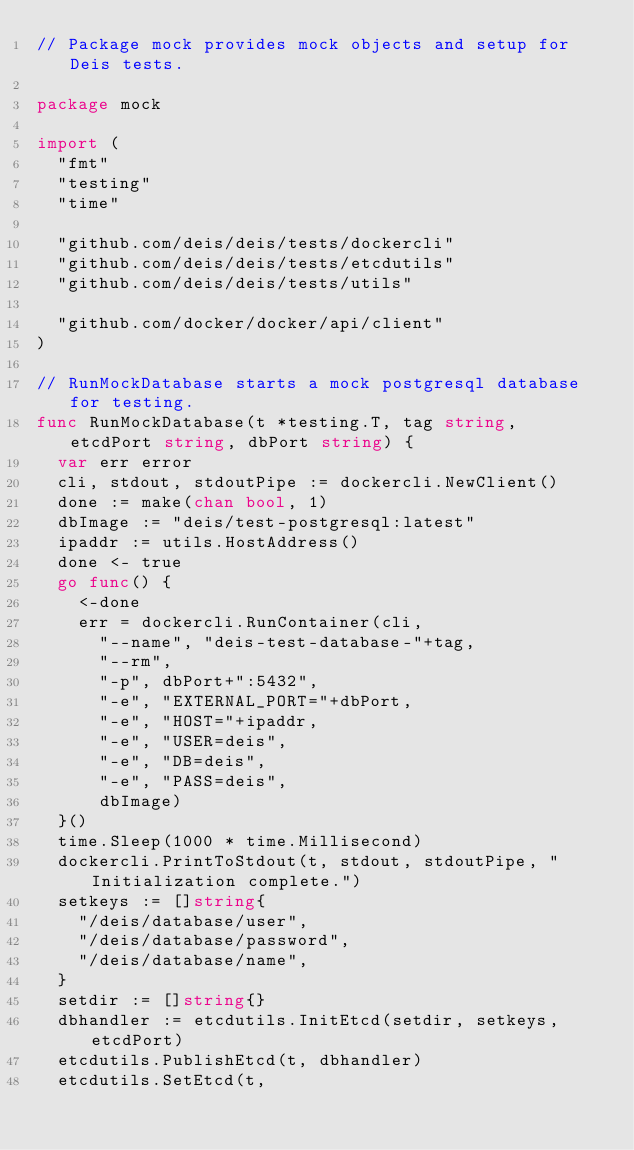<code> <loc_0><loc_0><loc_500><loc_500><_Go_>// Package mock provides mock objects and setup for Deis tests.

package mock

import (
	"fmt"
	"testing"
	"time"

	"github.com/deis/deis/tests/dockercli"
	"github.com/deis/deis/tests/etcdutils"
	"github.com/deis/deis/tests/utils"

	"github.com/docker/docker/api/client"
)

// RunMockDatabase starts a mock postgresql database for testing.
func RunMockDatabase(t *testing.T, tag string, etcdPort string, dbPort string) {
	var err error
	cli, stdout, stdoutPipe := dockercli.NewClient()
	done := make(chan bool, 1)
	dbImage := "deis/test-postgresql:latest"
	ipaddr := utils.HostAddress()
	done <- true
	go func() {
		<-done
		err = dockercli.RunContainer(cli,
			"--name", "deis-test-database-"+tag,
			"--rm",
			"-p", dbPort+":5432",
			"-e", "EXTERNAL_PORT="+dbPort,
			"-e", "HOST="+ipaddr,
			"-e", "USER=deis",
			"-e", "DB=deis",
			"-e", "PASS=deis",
			dbImage)
	}()
	time.Sleep(1000 * time.Millisecond)
	dockercli.PrintToStdout(t, stdout, stdoutPipe, "Initialization complete.")
	setkeys := []string{
		"/deis/database/user",
		"/deis/database/password",
		"/deis/database/name",
	}
	setdir := []string{}
	dbhandler := etcdutils.InitEtcd(setdir, setkeys, etcdPort)
	etcdutils.PublishEtcd(t, dbhandler)
	etcdutils.SetEtcd(t,</code> 